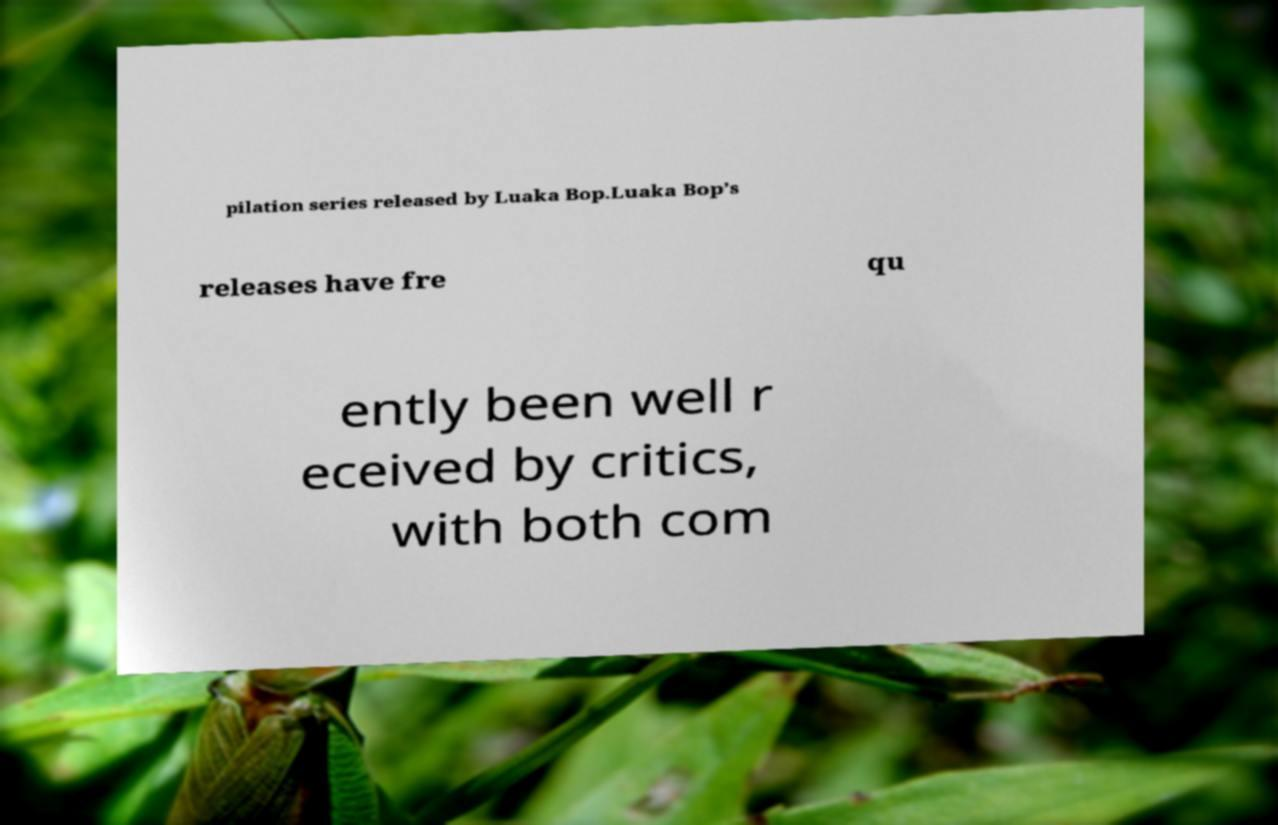There's text embedded in this image that I need extracted. Can you transcribe it verbatim? pilation series released by Luaka Bop.Luaka Bop’s releases have fre qu ently been well r eceived by critics, with both com 